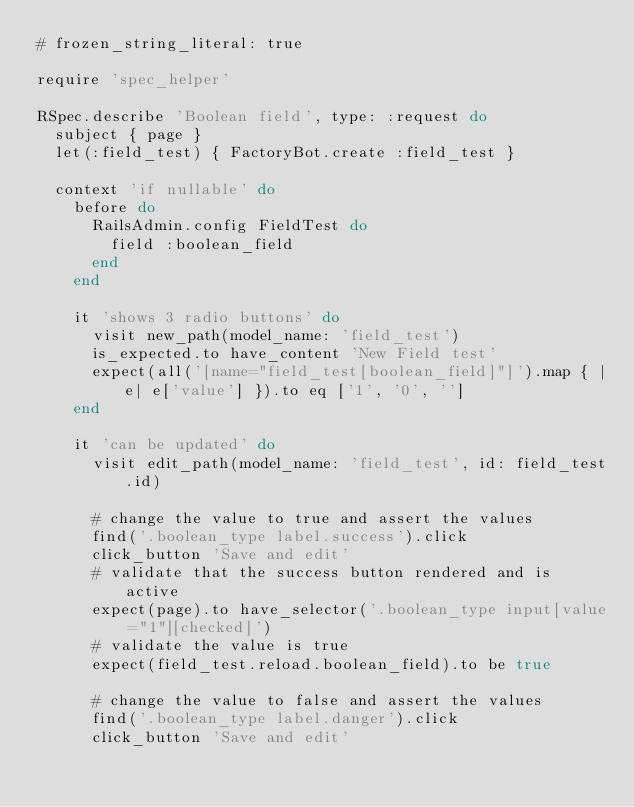Convert code to text. <code><loc_0><loc_0><loc_500><loc_500><_Ruby_># frozen_string_literal: true

require 'spec_helper'

RSpec.describe 'Boolean field', type: :request do
  subject { page }
  let(:field_test) { FactoryBot.create :field_test }

  context 'if nullable' do
    before do
      RailsAdmin.config FieldTest do
        field :boolean_field
      end
    end

    it 'shows 3 radio buttons' do
      visit new_path(model_name: 'field_test')
      is_expected.to have_content 'New Field test'
      expect(all('[name="field_test[boolean_field]"]').map { |e| e['value'] }).to eq ['1', '0', '']
    end

    it 'can be updated' do
      visit edit_path(model_name: 'field_test', id: field_test.id)

      # change the value to true and assert the values
      find('.boolean_type label.success').click
      click_button 'Save and edit'
      # validate that the success button rendered and is active
      expect(page).to have_selector('.boolean_type input[value="1"][checked]')
      # validate the value is true
      expect(field_test.reload.boolean_field).to be true

      # change the value to false and assert the values
      find('.boolean_type label.danger').click
      click_button 'Save and edit'</code> 